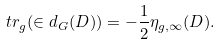Convert formula to latex. <formula><loc_0><loc_0><loc_500><loc_500>\ t r _ { g } ( \in d _ { G } ( D ) ) = - \frac { 1 } { 2 } \eta _ { g , \infty } ( D ) .</formula> 